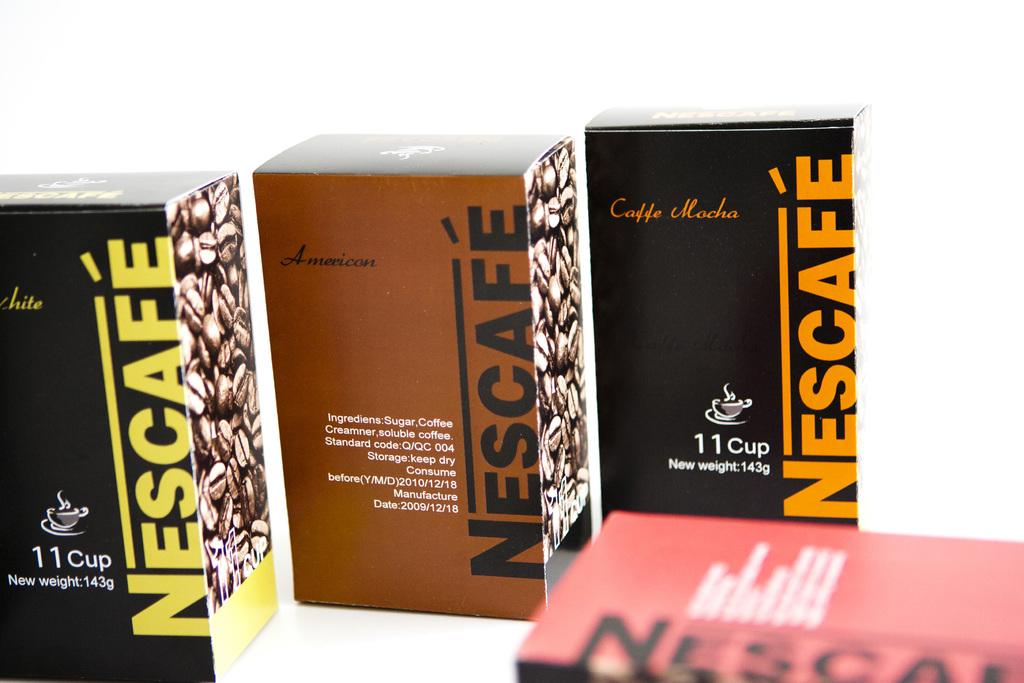<image>
Share a concise interpretation of the image provided. Three boxes of Nescafe sit next to each other. 